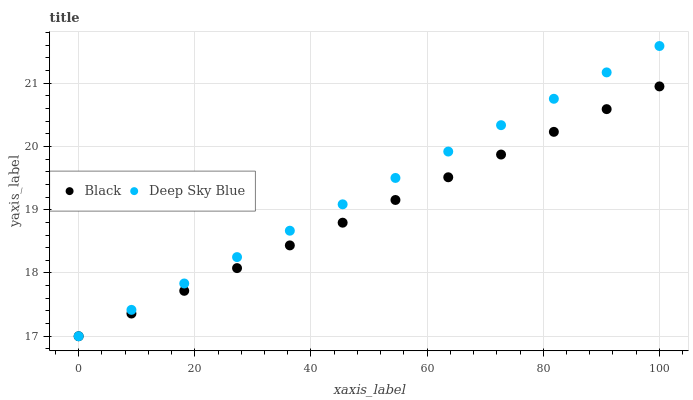Does Black have the minimum area under the curve?
Answer yes or no. Yes. Does Deep Sky Blue have the maximum area under the curve?
Answer yes or no. Yes. Does Deep Sky Blue have the minimum area under the curve?
Answer yes or no. No. Is Deep Sky Blue the smoothest?
Answer yes or no. Yes. Is Black the roughest?
Answer yes or no. Yes. Is Deep Sky Blue the roughest?
Answer yes or no. No. Does Black have the lowest value?
Answer yes or no. Yes. Does Deep Sky Blue have the highest value?
Answer yes or no. Yes. Does Deep Sky Blue intersect Black?
Answer yes or no. Yes. Is Deep Sky Blue less than Black?
Answer yes or no. No. Is Deep Sky Blue greater than Black?
Answer yes or no. No. 